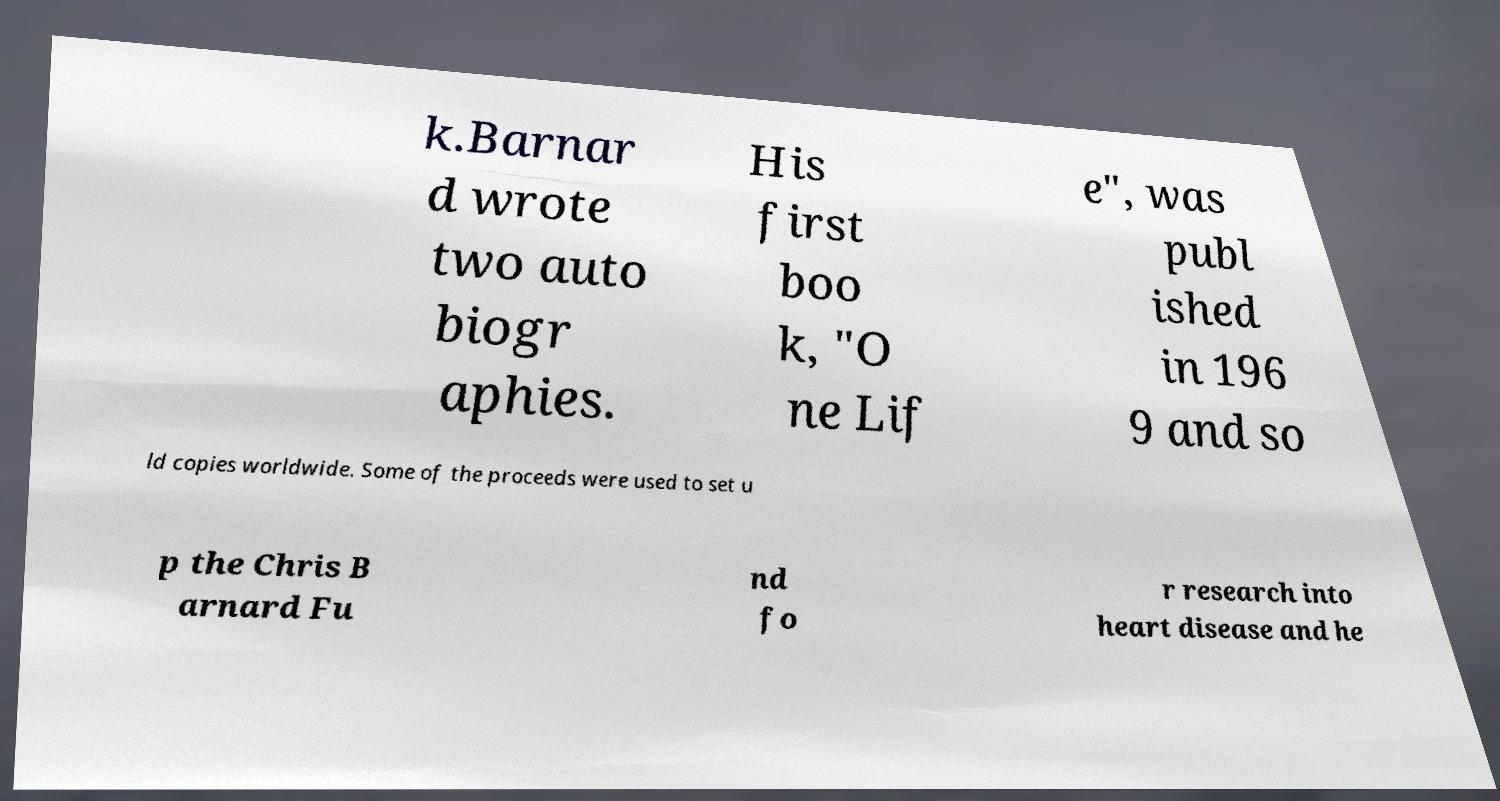Can you read and provide the text displayed in the image?This photo seems to have some interesting text. Can you extract and type it out for me? k.Barnar d wrote two auto biogr aphies. His first boo k, "O ne Lif e", was publ ished in 196 9 and so ld copies worldwide. Some of the proceeds were used to set u p the Chris B arnard Fu nd fo r research into heart disease and he 